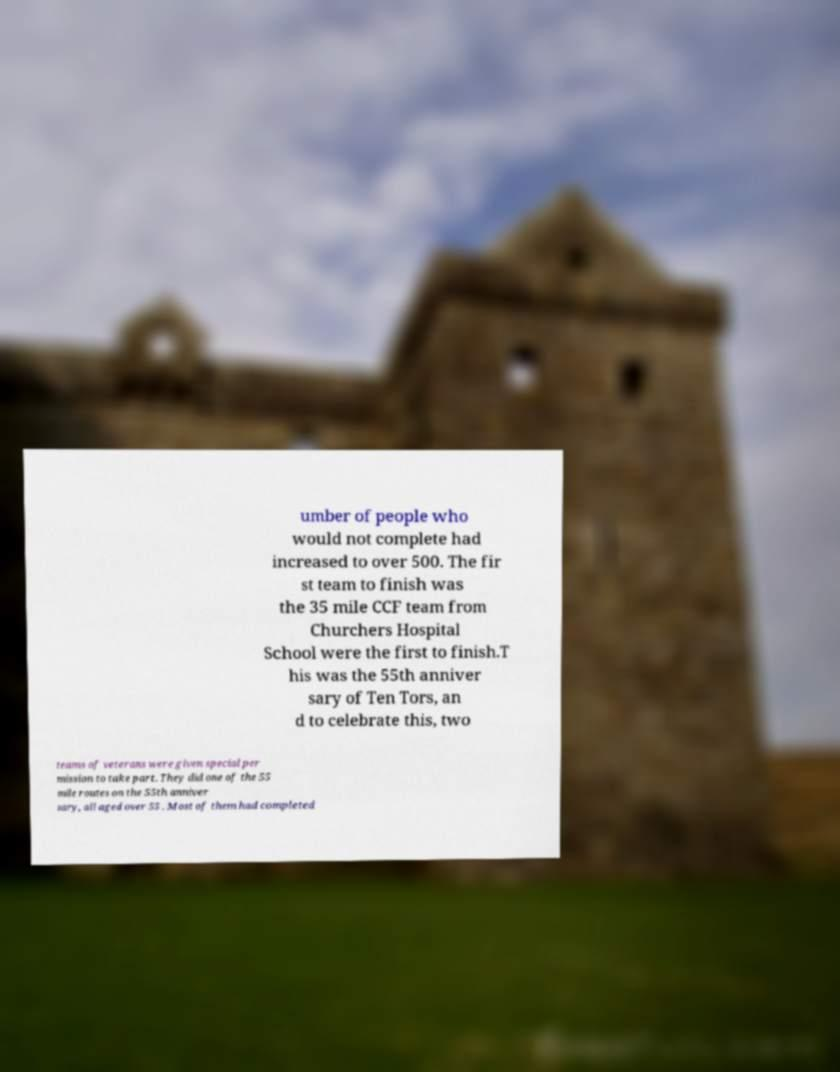Can you read and provide the text displayed in the image?This photo seems to have some interesting text. Can you extract and type it out for me? umber of people who would not complete had increased to over 500. The fir st team to finish was the 35 mile CCF team from Churchers Hospital School were the first to finish.T his was the 55th anniver sary of Ten Tors, an d to celebrate this, two teams of veterans were given special per mission to take part. They did one of the 55 mile routes on the 55th anniver sary, all aged over 55 . Most of them had completed 